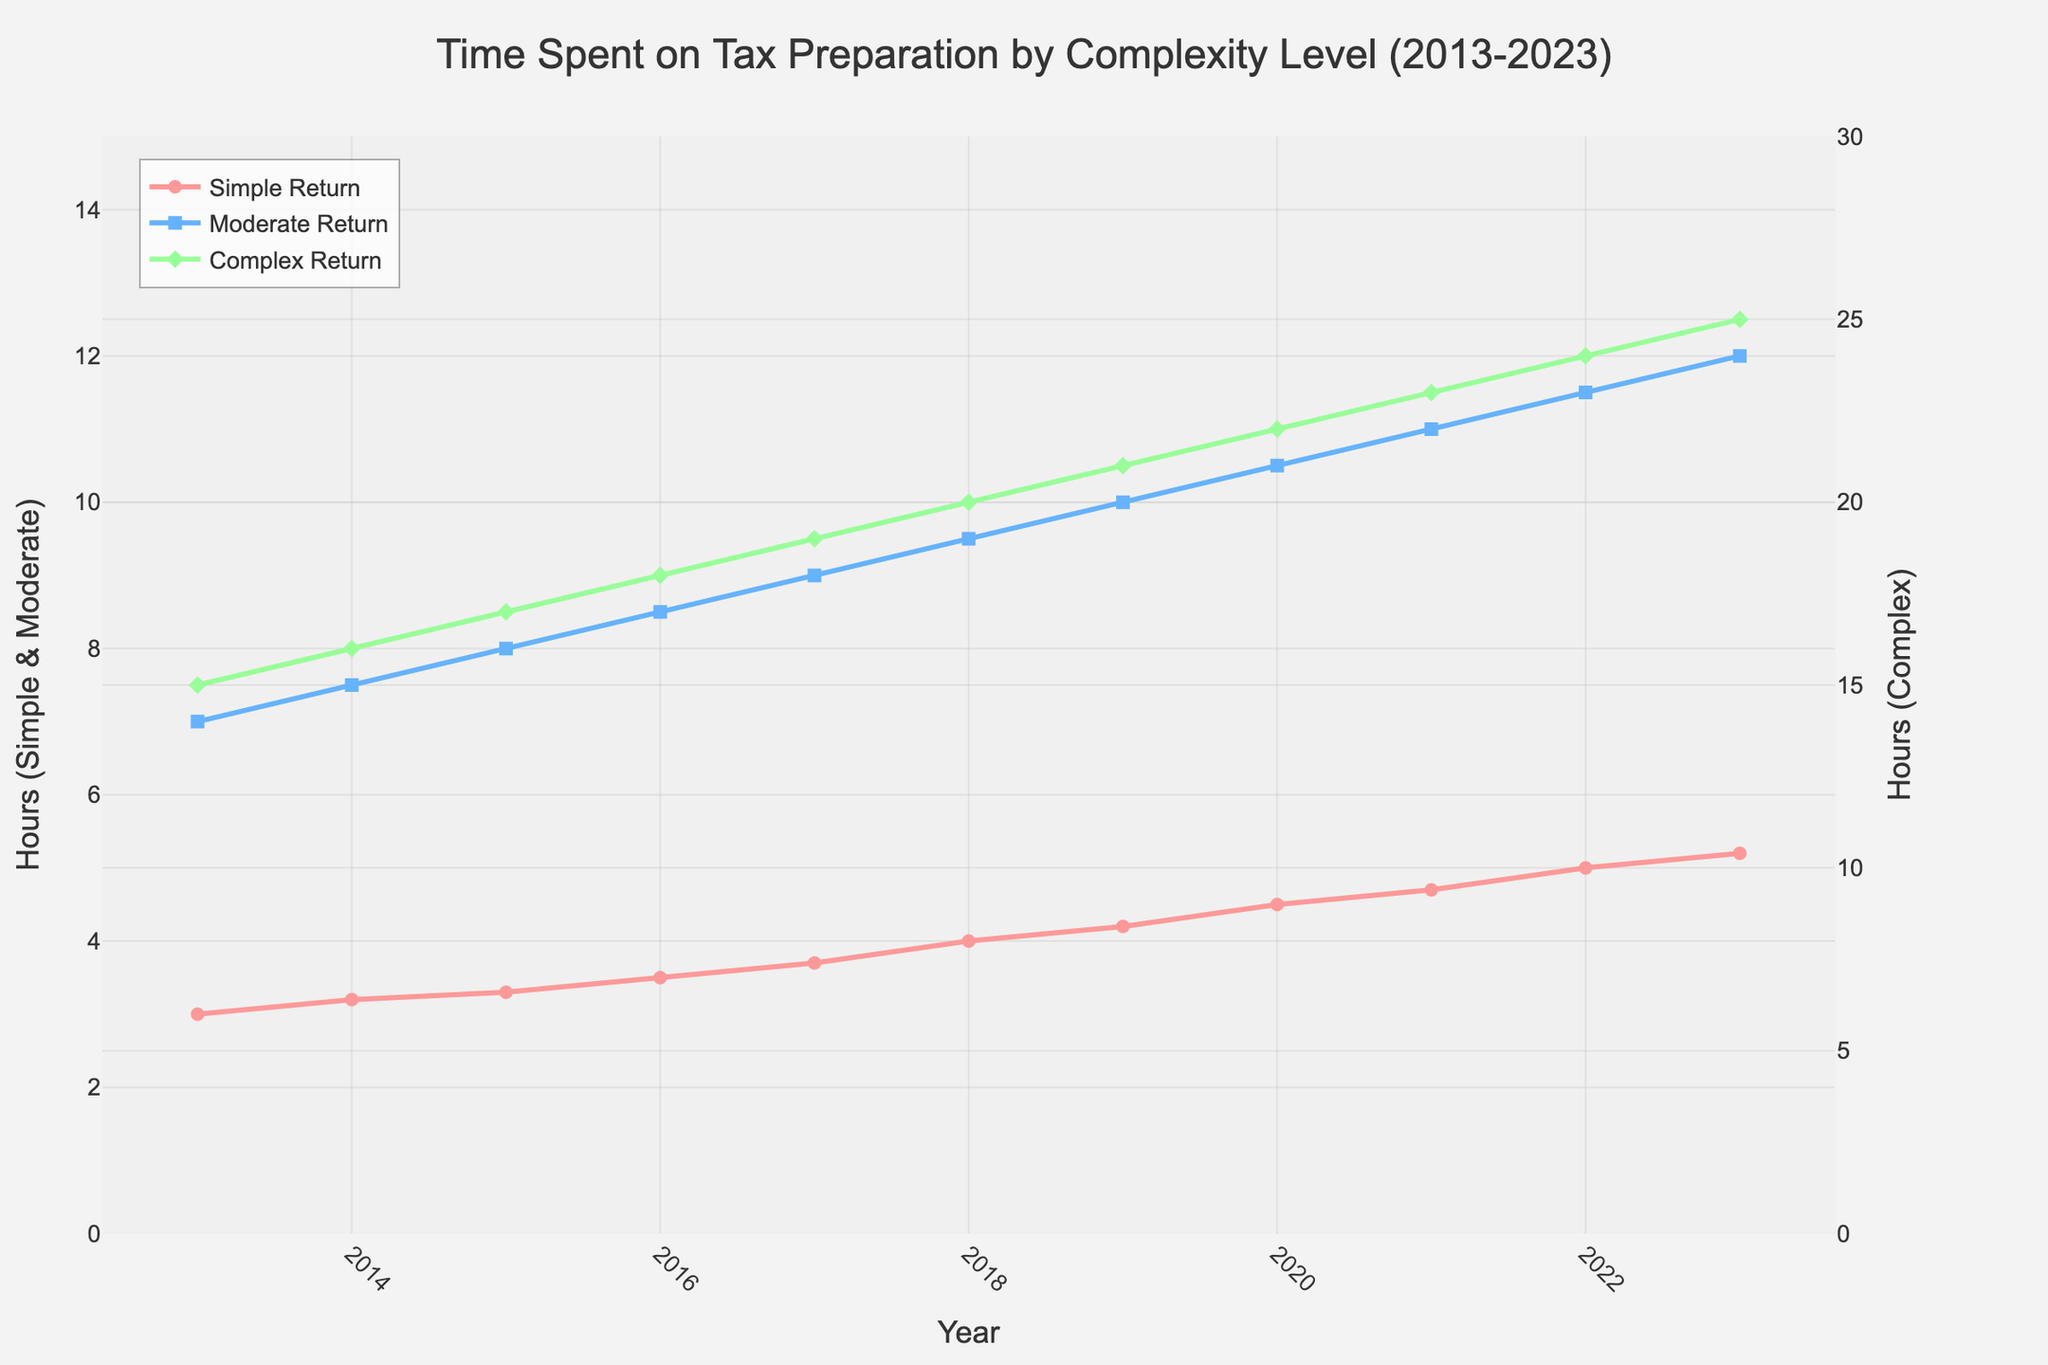Which tax return complexity level shows the largest increase in time spent on preparation from 2013 to 2023? To find the largest increase, calculate the difference in time spent on tax preparation from 2013 to 2023 for each complexity level: Simple Return (5.2 - 3), Moderate Return (12 - 7), Complex Return (25 - 15). The increases are 2.2, 5, and 10 hours respectively. Complex Return has the largest increase.
Answer: Complex Return For which complexity level does tax preparation time exceed 10 hours first, and in which year? To determine when the preparation time exceeds 10 hours, observe the time values across years for each complexity level: Simple Return never exceeds 10 hours, Moderate Return exceeds 10 hours in 2021, and Complex Return exceeds 10 hours before 2013. Thus, Moderate Return first exceeds 10 hours in 2021.
Answer: Moderate Return, 2021 By how much does the time spent on a Simple Return increase from 2013 to 2018? Subtract the time in 2013 from the time in 2018 for Simple Return: 4 - 3. This results in an increase of 1 hour.
Answer: 1 hour Compare the time spent on Moderate Return in 2017 with Complex Return in 2015. Which one is higher and by how much? The time spent on Moderate Return in 2017 is 9 hours and on Complex Return in 2015 is 17 hours. Subtract 9 from 17 to find the difference, which is 8 hours. Complex Return in 2015 is higher by 8 hours.
Answer: Complex Return (2015) by 8 hours What is the average time spent on Complex Return over the decade? Sum the times for Complex Return from 2013 to 2023 and divide by the number of years: (15 + 16 + 17 + 18 + 19 + 20 + 21 + 22 + 23 + 24 + 25) / 11 = 220 / 11 = 20 hours.
Answer: 20 hours How much more time was spent on Complex Returns than Simple Returns in 2023? Subtract the time for Simple Returns from the time for Complex Returns in 2023: 25 - 5.2 = 19.8 hours.
Answer: 19.8 hours 